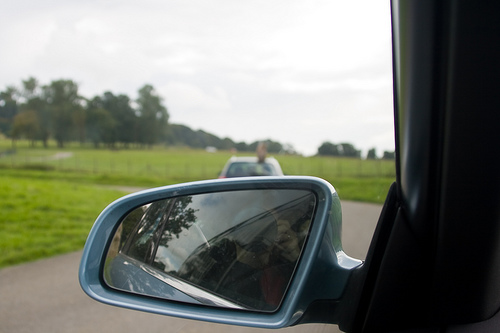<image>
Is there a grass behind the mirror? Yes. From this viewpoint, the grass is positioned behind the mirror, with the mirror partially or fully occluding the grass. Where is the mirror in relation to the camera? Is it behind the camera? No. The mirror is not behind the camera. From this viewpoint, the mirror appears to be positioned elsewhere in the scene. 